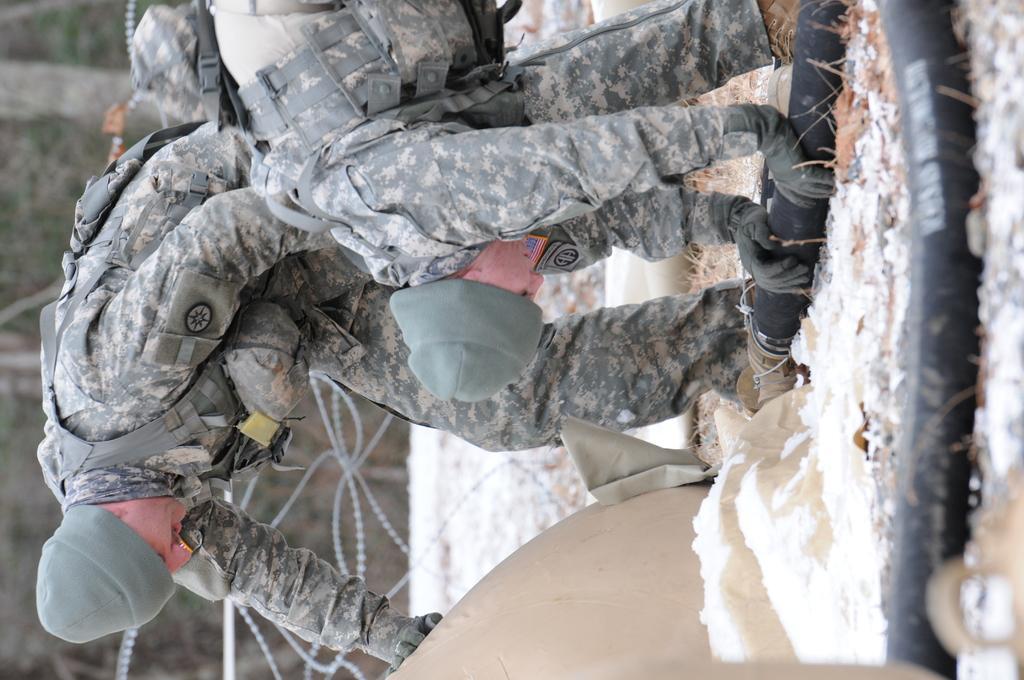Can you describe this image briefly? This picture is in leftward direction. On the top, there are two men wearing uniforms. One of the man is holding a pipe. On the ground, there is a snow. In the background, there are trees and fence. 